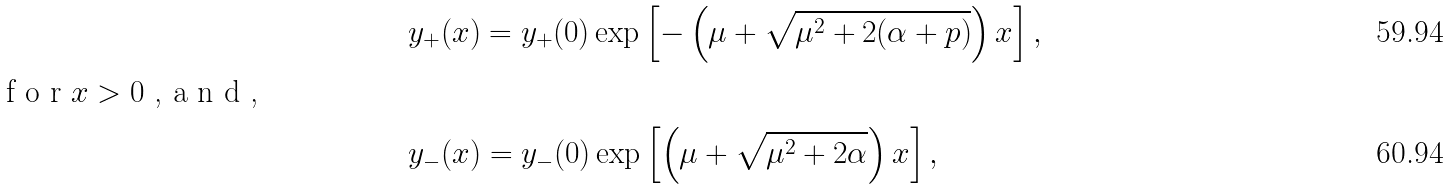<formula> <loc_0><loc_0><loc_500><loc_500>& y _ { + } ( x ) = y _ { + } ( 0 ) \exp \left [ - \left ( \mu + \sqrt { \mu ^ { 2 } + 2 ( \alpha + p ) } \right ) x \right ] , \\ \intertext { f o r $ x > 0 $ , a n d , } & y _ { - } ( x ) = y _ { - } ( 0 ) \exp \left [ \left ( \mu + \sqrt { \mu ^ { 2 } + 2 \alpha } \right ) x \right ] ,</formula> 